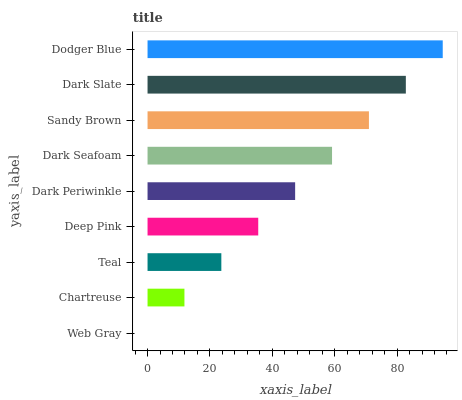Is Web Gray the minimum?
Answer yes or no. Yes. Is Dodger Blue the maximum?
Answer yes or no. Yes. Is Chartreuse the minimum?
Answer yes or no. No. Is Chartreuse the maximum?
Answer yes or no. No. Is Chartreuse greater than Web Gray?
Answer yes or no. Yes. Is Web Gray less than Chartreuse?
Answer yes or no. Yes. Is Web Gray greater than Chartreuse?
Answer yes or no. No. Is Chartreuse less than Web Gray?
Answer yes or no. No. Is Dark Periwinkle the high median?
Answer yes or no. Yes. Is Dark Periwinkle the low median?
Answer yes or no. Yes. Is Dark Slate the high median?
Answer yes or no. No. Is Sandy Brown the low median?
Answer yes or no. No. 